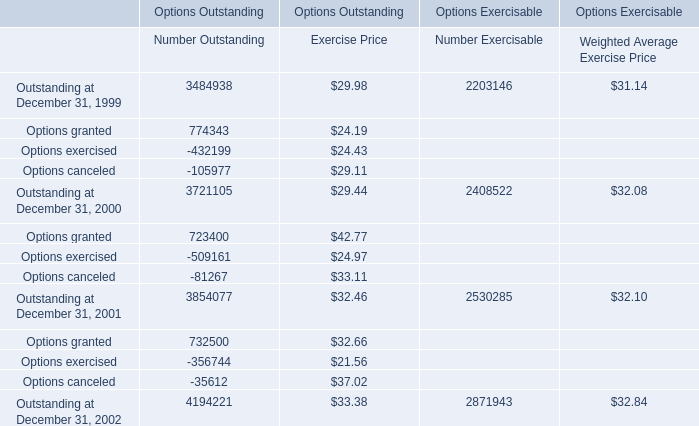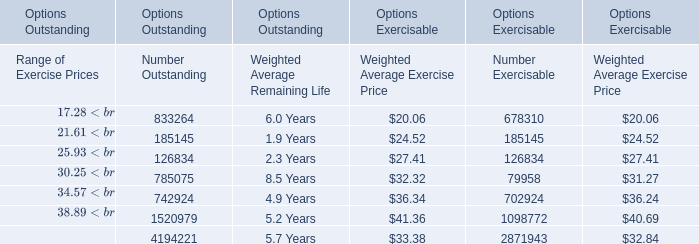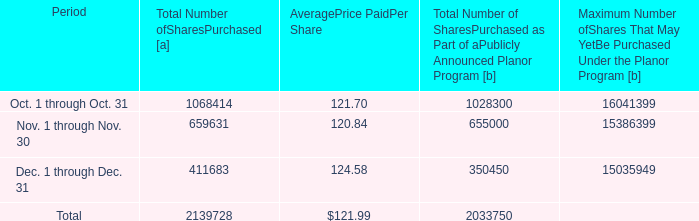what was the cost of total share repurchases during 2012? 
Computations: (13804709 * 115.33)
Answer: 1592097088.97. 